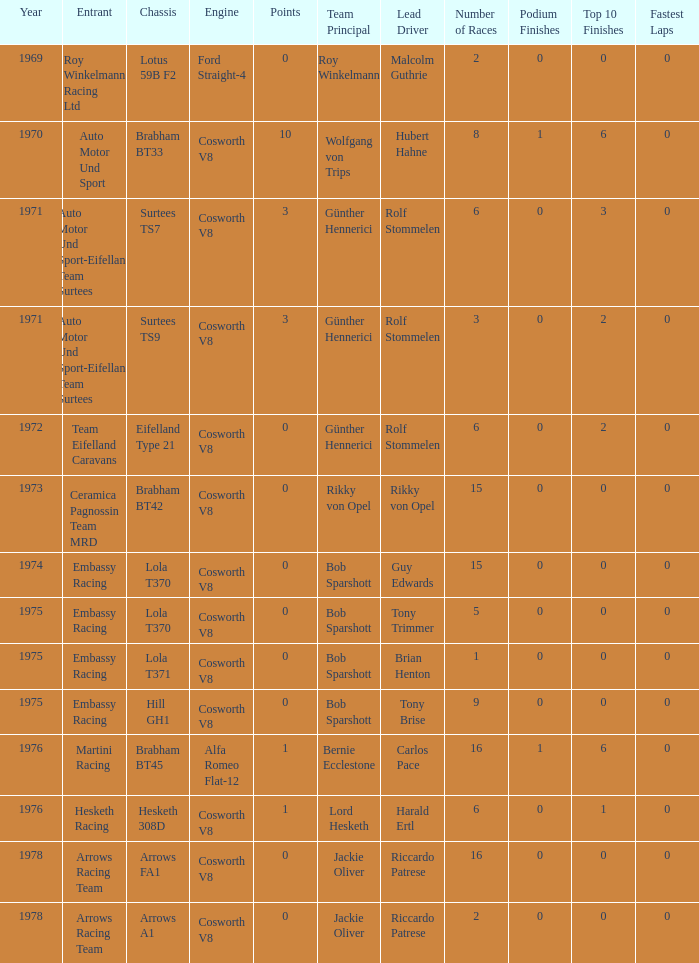Who was the entrant in 1971? Auto Motor Und Sport-Eifelland Team Surtees, Auto Motor Und Sport-Eifelland Team Surtees. 